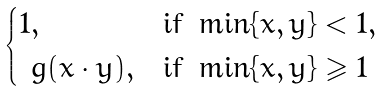<formula> <loc_0><loc_0><loc_500><loc_500>\begin{cases} 1 , & \text {if } \min \{ x , y \} < 1 , \\ \ g ( x \cdot y ) , & \text {if } \min \{ x , y \} \geqslant 1 \end{cases}</formula> 